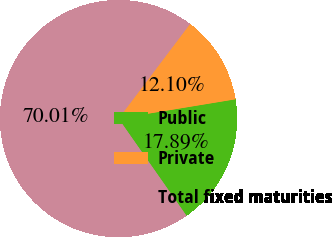Convert chart to OTSL. <chart><loc_0><loc_0><loc_500><loc_500><pie_chart><fcel>Public<fcel>Private<fcel>Total fixed maturities<nl><fcel>17.89%<fcel>12.1%<fcel>70.01%<nl></chart> 